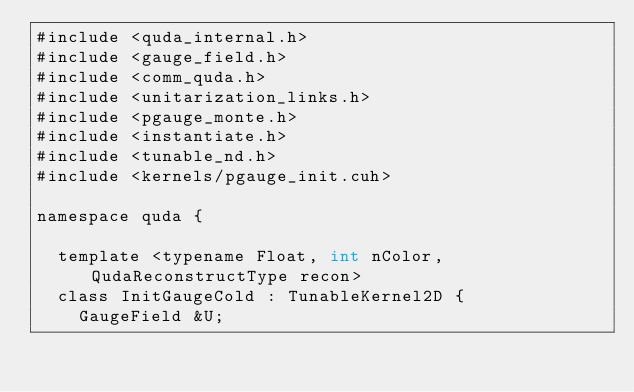<code> <loc_0><loc_0><loc_500><loc_500><_Cuda_>#include <quda_internal.h>
#include <gauge_field.h>
#include <comm_quda.h>
#include <unitarization_links.h>
#include <pgauge_monte.h>
#include <instantiate.h>
#include <tunable_nd.h>
#include <kernels/pgauge_init.cuh>

namespace quda {

  template <typename Float, int nColor, QudaReconstructType recon>
  class InitGaugeCold : TunableKernel2D {
    GaugeField &U;</code> 